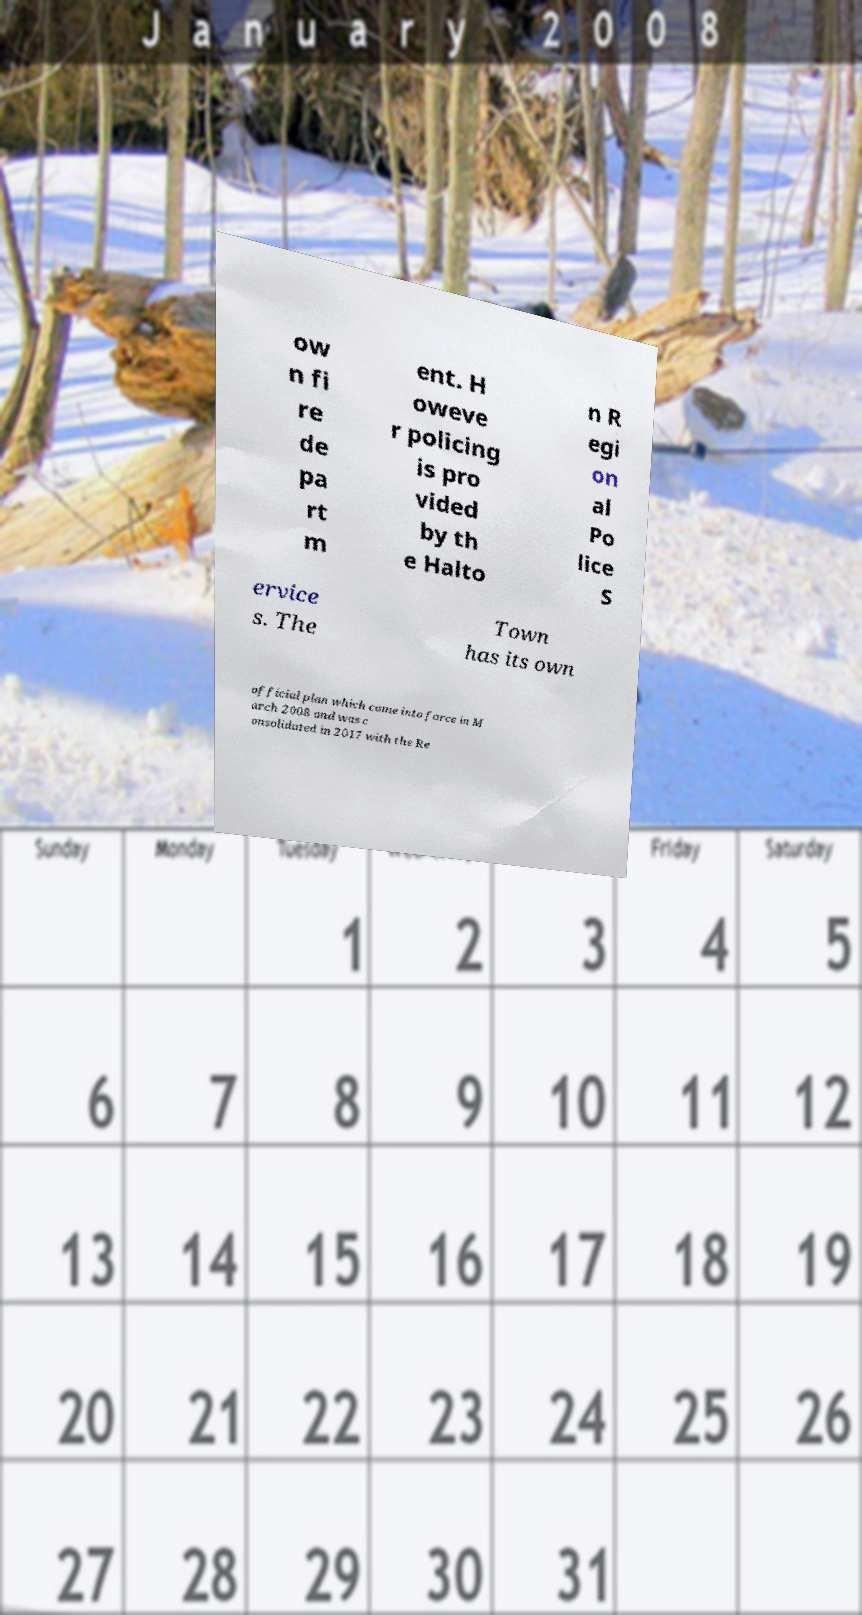There's text embedded in this image that I need extracted. Can you transcribe it verbatim? ow n fi re de pa rt m ent. H oweve r policing is pro vided by th e Halto n R egi on al Po lice S ervice s. The Town has its own official plan which came into force in M arch 2008 and was c onsolidated in 2017 with the Re 